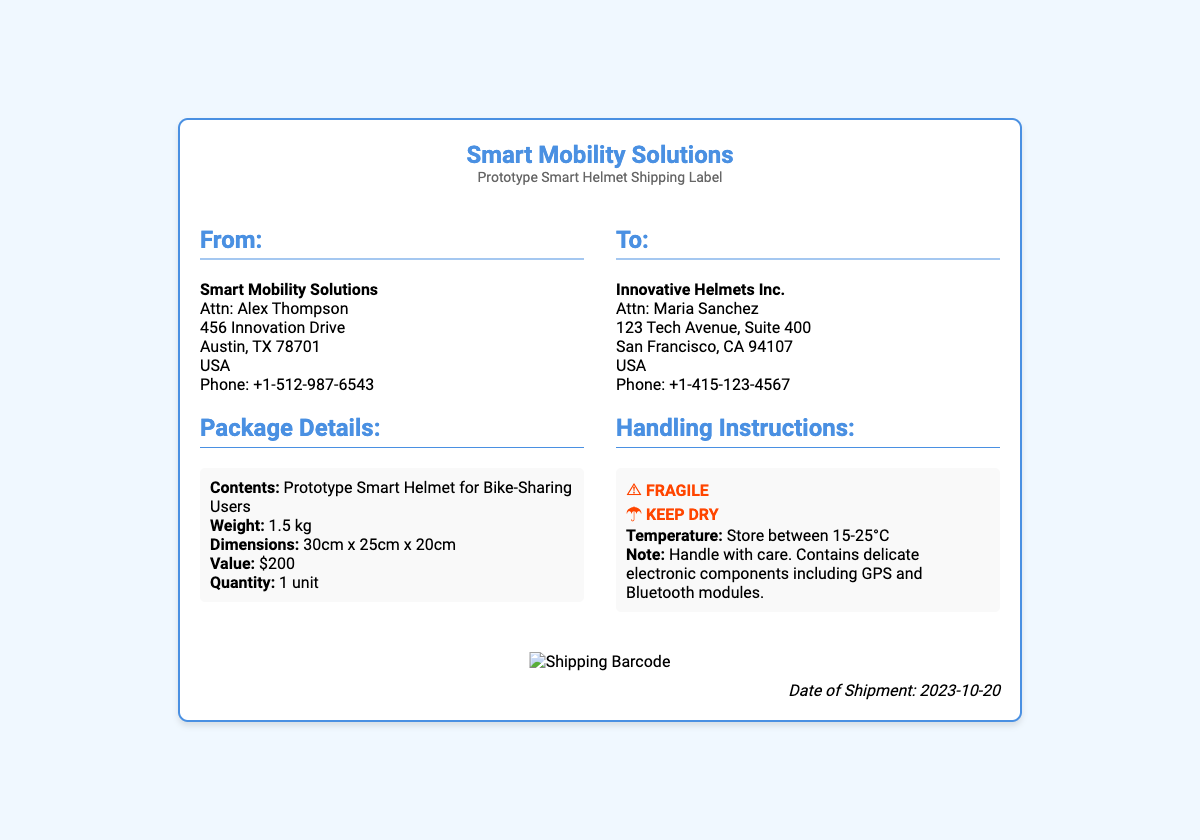what is the weight of the prototype smart helmet? The weight of the prototype smart helmet is specified under the package details section of the document.
Answer: 1.5 kg what are the dimensions of the package? The dimensions of the package are stated in the package details section.
Answer: 30cm x 25cm x 20cm who is the recipient of the shipment? The recipient's name is provided in the "To" section of the document.
Answer: Maria Sanchez what is the value of the prototype helmet? The value of the prototype helmet is mentioned in the package details section.
Answer: $200 what handling instruction is associated with the item? The handling instructions indicate specific care guidelines listed in the document.
Answer: FRAGILE where is the shipment being sent to? The shipping address is highlighted in the "To" section of the document.
Answer: 123 Tech Avenue, Suite 400, San Francisco, CA 94107, USA what is the date of shipment? The shipment date is indicated at the bottom of the document.
Answer: 2023-10-20 how many units are being shipped? The quantity of units is specified in the package details section.
Answer: 1 unit what temperature should the helmet be stored at? The storage temperature is mentioned under the handling instructions.
Answer: 15-25°C 